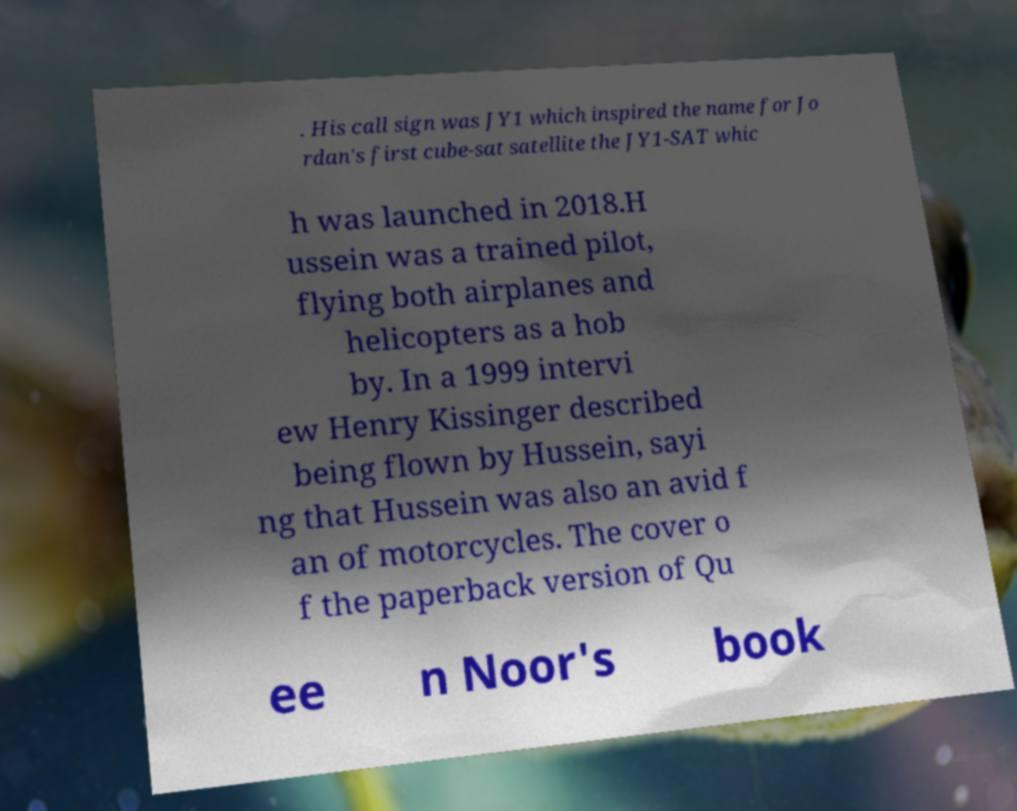Please read and relay the text visible in this image. What does it say? . His call sign was JY1 which inspired the name for Jo rdan's first cube-sat satellite the JY1-SAT whic h was launched in 2018.H ussein was a trained pilot, flying both airplanes and helicopters as a hob by. In a 1999 intervi ew Henry Kissinger described being flown by Hussein, sayi ng that Hussein was also an avid f an of motorcycles. The cover o f the paperback version of Qu ee n Noor's book 